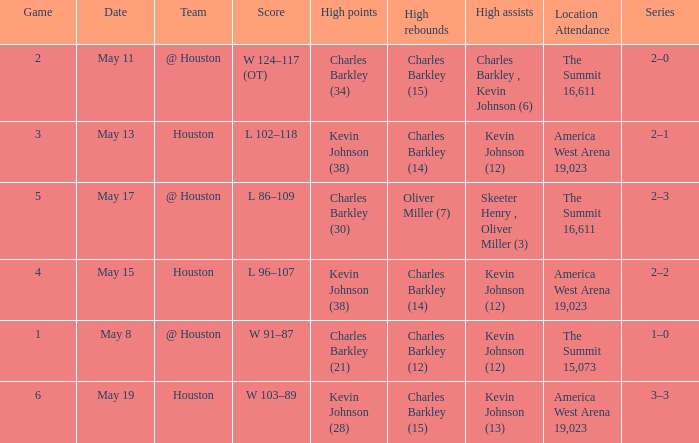In how many different games did Oliver Miller (7) did the high rebounds? 1.0. 